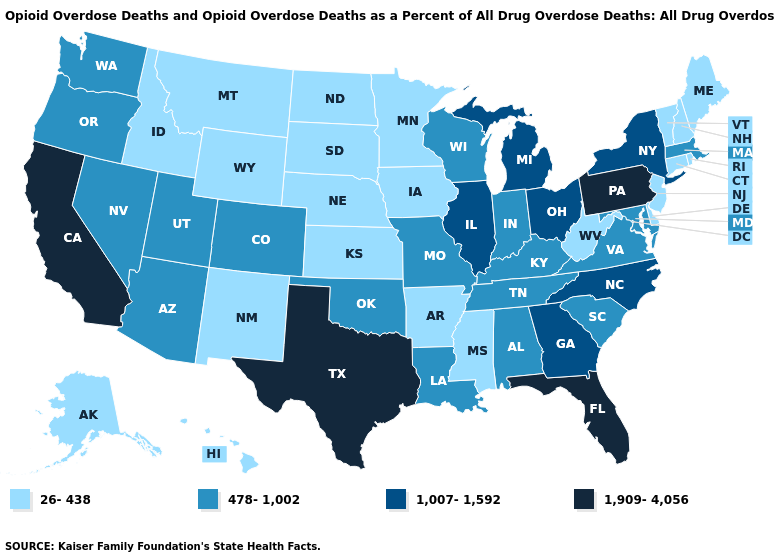Does the first symbol in the legend represent the smallest category?
Quick response, please. Yes. Among the states that border New Hampshire , does Massachusetts have the lowest value?
Be succinct. No. Does Alabama have the lowest value in the South?
Write a very short answer. No. What is the value of Vermont?
Write a very short answer. 26-438. Does the first symbol in the legend represent the smallest category?
Concise answer only. Yes. Does Hawaii have the lowest value in the West?
Short answer required. Yes. Name the states that have a value in the range 1,007-1,592?
Be succinct. Georgia, Illinois, Michigan, New York, North Carolina, Ohio. Which states have the highest value in the USA?
Quick response, please. California, Florida, Pennsylvania, Texas. What is the value of Delaware?
Give a very brief answer. 26-438. Among the states that border Louisiana , does Texas have the highest value?
Short answer required. Yes. Name the states that have a value in the range 1,007-1,592?
Write a very short answer. Georgia, Illinois, Michigan, New York, North Carolina, Ohio. Name the states that have a value in the range 478-1,002?
Answer briefly. Alabama, Arizona, Colorado, Indiana, Kentucky, Louisiana, Maryland, Massachusetts, Missouri, Nevada, Oklahoma, Oregon, South Carolina, Tennessee, Utah, Virginia, Washington, Wisconsin. Among the states that border Nebraska , which have the highest value?
Keep it brief. Colorado, Missouri. Which states hav the highest value in the South?
Concise answer only. Florida, Texas. What is the value of Arkansas?
Write a very short answer. 26-438. 